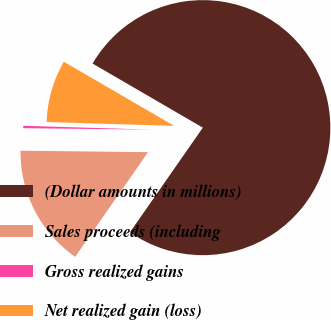Convert chart. <chart><loc_0><loc_0><loc_500><loc_500><pie_chart><fcel>(Dollar amounts in millions)<fcel>Sales proceeds (including<fcel>Gross realized gains<fcel>Net realized gain (loss)<nl><fcel>76.29%<fcel>15.5%<fcel>0.3%<fcel>7.9%<nl></chart> 